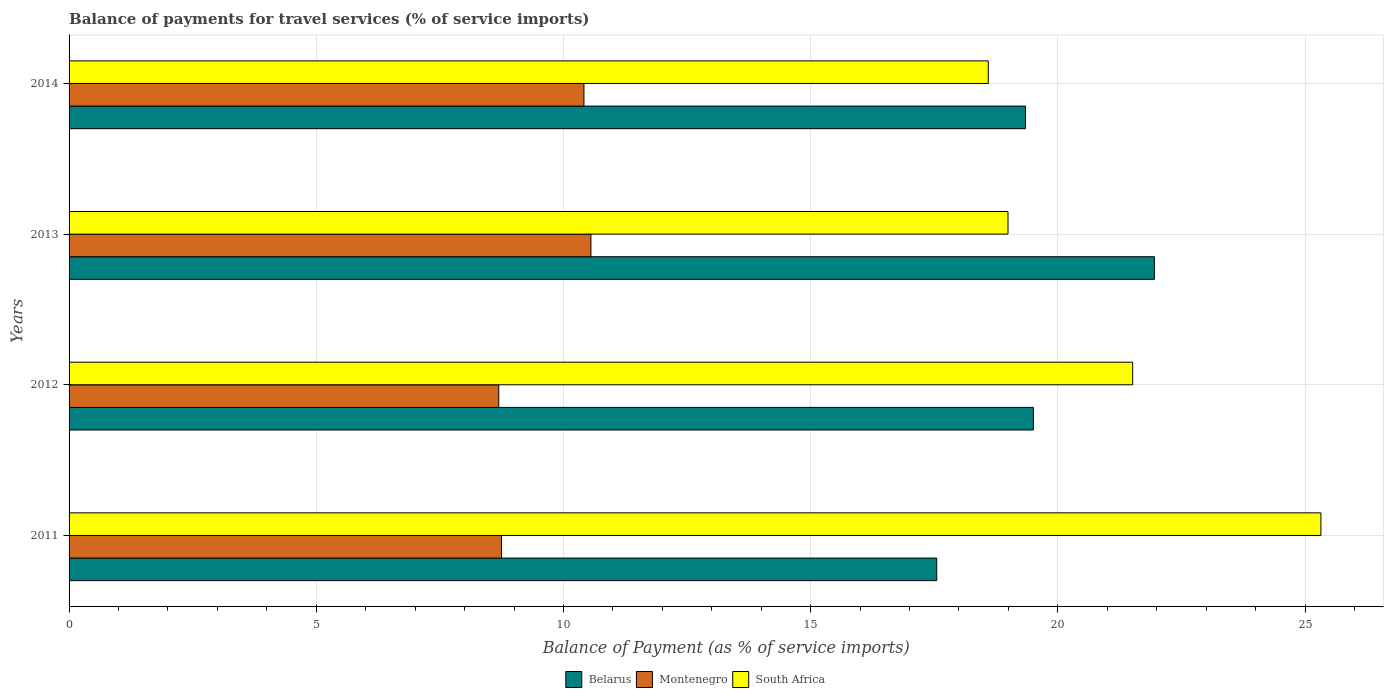How many bars are there on the 2nd tick from the top?
Offer a very short reply. 3. How many bars are there on the 4th tick from the bottom?
Ensure brevity in your answer.  3. What is the label of the 3rd group of bars from the top?
Provide a short and direct response. 2012. In how many cases, is the number of bars for a given year not equal to the number of legend labels?
Your answer should be compact. 0. What is the balance of payments for travel services in Montenegro in 2014?
Your answer should be very brief. 10.41. Across all years, what is the maximum balance of payments for travel services in South Africa?
Provide a succinct answer. 25.32. Across all years, what is the minimum balance of payments for travel services in Montenegro?
Ensure brevity in your answer.  8.69. In which year was the balance of payments for travel services in Belarus minimum?
Your answer should be compact. 2011. What is the total balance of payments for travel services in Belarus in the graph?
Keep it short and to the point. 78.35. What is the difference between the balance of payments for travel services in South Africa in 2012 and that in 2013?
Your answer should be compact. 2.52. What is the difference between the balance of payments for travel services in South Africa in 2013 and the balance of payments for travel services in Montenegro in 2012?
Ensure brevity in your answer.  10.3. What is the average balance of payments for travel services in Belarus per year?
Your answer should be very brief. 19.59. In the year 2014, what is the difference between the balance of payments for travel services in Belarus and balance of payments for travel services in South Africa?
Your answer should be compact. 0.75. In how many years, is the balance of payments for travel services in Belarus greater than 15 %?
Your answer should be very brief. 4. What is the ratio of the balance of payments for travel services in Montenegro in 2013 to that in 2014?
Provide a short and direct response. 1.01. Is the balance of payments for travel services in Belarus in 2012 less than that in 2014?
Keep it short and to the point. No. What is the difference between the highest and the second highest balance of payments for travel services in Belarus?
Your response must be concise. 2.45. What is the difference between the highest and the lowest balance of payments for travel services in Belarus?
Provide a succinct answer. 4.4. In how many years, is the balance of payments for travel services in South Africa greater than the average balance of payments for travel services in South Africa taken over all years?
Provide a short and direct response. 2. Is the sum of the balance of payments for travel services in South Africa in 2012 and 2014 greater than the maximum balance of payments for travel services in Belarus across all years?
Offer a very short reply. Yes. What does the 3rd bar from the top in 2014 represents?
Provide a short and direct response. Belarus. What does the 1st bar from the bottom in 2012 represents?
Make the answer very short. Belarus. How many bars are there?
Keep it short and to the point. 12. Are all the bars in the graph horizontal?
Ensure brevity in your answer.  Yes. What is the difference between two consecutive major ticks on the X-axis?
Your response must be concise. 5. Are the values on the major ticks of X-axis written in scientific E-notation?
Offer a terse response. No. Where does the legend appear in the graph?
Offer a terse response. Bottom center. What is the title of the graph?
Make the answer very short. Balance of payments for travel services (% of service imports). Does "St. Kitts and Nevis" appear as one of the legend labels in the graph?
Provide a succinct answer. No. What is the label or title of the X-axis?
Offer a very short reply. Balance of Payment (as % of service imports). What is the label or title of the Y-axis?
Provide a short and direct response. Years. What is the Balance of Payment (as % of service imports) in Belarus in 2011?
Offer a terse response. 17.55. What is the Balance of Payment (as % of service imports) of Montenegro in 2011?
Keep it short and to the point. 8.75. What is the Balance of Payment (as % of service imports) of South Africa in 2011?
Offer a terse response. 25.32. What is the Balance of Payment (as % of service imports) in Belarus in 2012?
Your answer should be compact. 19.5. What is the Balance of Payment (as % of service imports) in Montenegro in 2012?
Keep it short and to the point. 8.69. What is the Balance of Payment (as % of service imports) in South Africa in 2012?
Your response must be concise. 21.51. What is the Balance of Payment (as % of service imports) in Belarus in 2013?
Offer a terse response. 21.95. What is the Balance of Payment (as % of service imports) of Montenegro in 2013?
Keep it short and to the point. 10.56. What is the Balance of Payment (as % of service imports) in South Africa in 2013?
Provide a succinct answer. 18.99. What is the Balance of Payment (as % of service imports) in Belarus in 2014?
Give a very brief answer. 19.35. What is the Balance of Payment (as % of service imports) of Montenegro in 2014?
Provide a succinct answer. 10.41. What is the Balance of Payment (as % of service imports) of South Africa in 2014?
Ensure brevity in your answer.  18.59. Across all years, what is the maximum Balance of Payment (as % of service imports) in Belarus?
Offer a very short reply. 21.95. Across all years, what is the maximum Balance of Payment (as % of service imports) of Montenegro?
Make the answer very short. 10.56. Across all years, what is the maximum Balance of Payment (as % of service imports) in South Africa?
Give a very brief answer. 25.32. Across all years, what is the minimum Balance of Payment (as % of service imports) of Belarus?
Provide a short and direct response. 17.55. Across all years, what is the minimum Balance of Payment (as % of service imports) in Montenegro?
Give a very brief answer. 8.69. Across all years, what is the minimum Balance of Payment (as % of service imports) of South Africa?
Keep it short and to the point. 18.59. What is the total Balance of Payment (as % of service imports) in Belarus in the graph?
Give a very brief answer. 78.35. What is the total Balance of Payment (as % of service imports) in Montenegro in the graph?
Make the answer very short. 38.41. What is the total Balance of Payment (as % of service imports) in South Africa in the graph?
Offer a very short reply. 84.42. What is the difference between the Balance of Payment (as % of service imports) in Belarus in 2011 and that in 2012?
Your answer should be very brief. -1.96. What is the difference between the Balance of Payment (as % of service imports) in Montenegro in 2011 and that in 2012?
Your response must be concise. 0.06. What is the difference between the Balance of Payment (as % of service imports) of South Africa in 2011 and that in 2012?
Keep it short and to the point. 3.81. What is the difference between the Balance of Payment (as % of service imports) of Belarus in 2011 and that in 2013?
Offer a terse response. -4.4. What is the difference between the Balance of Payment (as % of service imports) in Montenegro in 2011 and that in 2013?
Offer a very short reply. -1.81. What is the difference between the Balance of Payment (as % of service imports) of South Africa in 2011 and that in 2013?
Your answer should be compact. 6.33. What is the difference between the Balance of Payment (as % of service imports) of Belarus in 2011 and that in 2014?
Provide a succinct answer. -1.8. What is the difference between the Balance of Payment (as % of service imports) in Montenegro in 2011 and that in 2014?
Give a very brief answer. -1.67. What is the difference between the Balance of Payment (as % of service imports) of South Africa in 2011 and that in 2014?
Make the answer very short. 6.73. What is the difference between the Balance of Payment (as % of service imports) in Belarus in 2012 and that in 2013?
Provide a short and direct response. -2.45. What is the difference between the Balance of Payment (as % of service imports) of Montenegro in 2012 and that in 2013?
Offer a very short reply. -1.86. What is the difference between the Balance of Payment (as % of service imports) in South Africa in 2012 and that in 2013?
Offer a terse response. 2.52. What is the difference between the Balance of Payment (as % of service imports) in Belarus in 2012 and that in 2014?
Make the answer very short. 0.16. What is the difference between the Balance of Payment (as % of service imports) of Montenegro in 2012 and that in 2014?
Ensure brevity in your answer.  -1.72. What is the difference between the Balance of Payment (as % of service imports) in South Africa in 2012 and that in 2014?
Provide a short and direct response. 2.92. What is the difference between the Balance of Payment (as % of service imports) of Belarus in 2013 and that in 2014?
Your response must be concise. 2.61. What is the difference between the Balance of Payment (as % of service imports) in Montenegro in 2013 and that in 2014?
Your response must be concise. 0.14. What is the difference between the Balance of Payment (as % of service imports) of South Africa in 2013 and that in 2014?
Offer a terse response. 0.4. What is the difference between the Balance of Payment (as % of service imports) of Belarus in 2011 and the Balance of Payment (as % of service imports) of Montenegro in 2012?
Offer a terse response. 8.86. What is the difference between the Balance of Payment (as % of service imports) of Belarus in 2011 and the Balance of Payment (as % of service imports) of South Africa in 2012?
Make the answer very short. -3.96. What is the difference between the Balance of Payment (as % of service imports) of Montenegro in 2011 and the Balance of Payment (as % of service imports) of South Africa in 2012?
Offer a very short reply. -12.77. What is the difference between the Balance of Payment (as % of service imports) in Belarus in 2011 and the Balance of Payment (as % of service imports) in Montenegro in 2013?
Your answer should be very brief. 6.99. What is the difference between the Balance of Payment (as % of service imports) in Belarus in 2011 and the Balance of Payment (as % of service imports) in South Africa in 2013?
Give a very brief answer. -1.44. What is the difference between the Balance of Payment (as % of service imports) in Montenegro in 2011 and the Balance of Payment (as % of service imports) in South Africa in 2013?
Make the answer very short. -10.24. What is the difference between the Balance of Payment (as % of service imports) in Belarus in 2011 and the Balance of Payment (as % of service imports) in Montenegro in 2014?
Ensure brevity in your answer.  7.14. What is the difference between the Balance of Payment (as % of service imports) in Belarus in 2011 and the Balance of Payment (as % of service imports) in South Africa in 2014?
Keep it short and to the point. -1.04. What is the difference between the Balance of Payment (as % of service imports) of Montenegro in 2011 and the Balance of Payment (as % of service imports) of South Africa in 2014?
Give a very brief answer. -9.85. What is the difference between the Balance of Payment (as % of service imports) in Belarus in 2012 and the Balance of Payment (as % of service imports) in Montenegro in 2013?
Provide a short and direct response. 8.95. What is the difference between the Balance of Payment (as % of service imports) of Belarus in 2012 and the Balance of Payment (as % of service imports) of South Africa in 2013?
Offer a terse response. 0.51. What is the difference between the Balance of Payment (as % of service imports) in Montenegro in 2012 and the Balance of Payment (as % of service imports) in South Africa in 2013?
Keep it short and to the point. -10.3. What is the difference between the Balance of Payment (as % of service imports) of Belarus in 2012 and the Balance of Payment (as % of service imports) of Montenegro in 2014?
Your response must be concise. 9.09. What is the difference between the Balance of Payment (as % of service imports) of Belarus in 2012 and the Balance of Payment (as % of service imports) of South Africa in 2014?
Give a very brief answer. 0.91. What is the difference between the Balance of Payment (as % of service imports) of Montenegro in 2012 and the Balance of Payment (as % of service imports) of South Africa in 2014?
Provide a succinct answer. -9.9. What is the difference between the Balance of Payment (as % of service imports) of Belarus in 2013 and the Balance of Payment (as % of service imports) of Montenegro in 2014?
Your answer should be compact. 11.54. What is the difference between the Balance of Payment (as % of service imports) in Belarus in 2013 and the Balance of Payment (as % of service imports) in South Africa in 2014?
Ensure brevity in your answer.  3.36. What is the difference between the Balance of Payment (as % of service imports) in Montenegro in 2013 and the Balance of Payment (as % of service imports) in South Africa in 2014?
Your answer should be very brief. -8.04. What is the average Balance of Payment (as % of service imports) in Belarus per year?
Offer a very short reply. 19.59. What is the average Balance of Payment (as % of service imports) of Montenegro per year?
Keep it short and to the point. 9.6. What is the average Balance of Payment (as % of service imports) of South Africa per year?
Your response must be concise. 21.1. In the year 2011, what is the difference between the Balance of Payment (as % of service imports) in Belarus and Balance of Payment (as % of service imports) in Montenegro?
Keep it short and to the point. 8.8. In the year 2011, what is the difference between the Balance of Payment (as % of service imports) in Belarus and Balance of Payment (as % of service imports) in South Africa?
Keep it short and to the point. -7.77. In the year 2011, what is the difference between the Balance of Payment (as % of service imports) of Montenegro and Balance of Payment (as % of service imports) of South Africa?
Offer a very short reply. -16.57. In the year 2012, what is the difference between the Balance of Payment (as % of service imports) in Belarus and Balance of Payment (as % of service imports) in Montenegro?
Your response must be concise. 10.81. In the year 2012, what is the difference between the Balance of Payment (as % of service imports) of Belarus and Balance of Payment (as % of service imports) of South Africa?
Offer a very short reply. -2.01. In the year 2012, what is the difference between the Balance of Payment (as % of service imports) of Montenegro and Balance of Payment (as % of service imports) of South Africa?
Provide a short and direct response. -12.82. In the year 2013, what is the difference between the Balance of Payment (as % of service imports) of Belarus and Balance of Payment (as % of service imports) of Montenegro?
Your response must be concise. 11.4. In the year 2013, what is the difference between the Balance of Payment (as % of service imports) in Belarus and Balance of Payment (as % of service imports) in South Africa?
Provide a short and direct response. 2.96. In the year 2013, what is the difference between the Balance of Payment (as % of service imports) in Montenegro and Balance of Payment (as % of service imports) in South Africa?
Offer a terse response. -8.44. In the year 2014, what is the difference between the Balance of Payment (as % of service imports) of Belarus and Balance of Payment (as % of service imports) of Montenegro?
Make the answer very short. 8.93. In the year 2014, what is the difference between the Balance of Payment (as % of service imports) of Belarus and Balance of Payment (as % of service imports) of South Africa?
Ensure brevity in your answer.  0.75. In the year 2014, what is the difference between the Balance of Payment (as % of service imports) in Montenegro and Balance of Payment (as % of service imports) in South Africa?
Your answer should be compact. -8.18. What is the ratio of the Balance of Payment (as % of service imports) of Belarus in 2011 to that in 2012?
Your answer should be compact. 0.9. What is the ratio of the Balance of Payment (as % of service imports) in Montenegro in 2011 to that in 2012?
Keep it short and to the point. 1.01. What is the ratio of the Balance of Payment (as % of service imports) in South Africa in 2011 to that in 2012?
Keep it short and to the point. 1.18. What is the ratio of the Balance of Payment (as % of service imports) of Belarus in 2011 to that in 2013?
Provide a succinct answer. 0.8. What is the ratio of the Balance of Payment (as % of service imports) in Montenegro in 2011 to that in 2013?
Provide a short and direct response. 0.83. What is the ratio of the Balance of Payment (as % of service imports) of South Africa in 2011 to that in 2013?
Ensure brevity in your answer.  1.33. What is the ratio of the Balance of Payment (as % of service imports) in Belarus in 2011 to that in 2014?
Your response must be concise. 0.91. What is the ratio of the Balance of Payment (as % of service imports) of Montenegro in 2011 to that in 2014?
Keep it short and to the point. 0.84. What is the ratio of the Balance of Payment (as % of service imports) of South Africa in 2011 to that in 2014?
Your response must be concise. 1.36. What is the ratio of the Balance of Payment (as % of service imports) in Belarus in 2012 to that in 2013?
Offer a terse response. 0.89. What is the ratio of the Balance of Payment (as % of service imports) of Montenegro in 2012 to that in 2013?
Your answer should be compact. 0.82. What is the ratio of the Balance of Payment (as % of service imports) in South Africa in 2012 to that in 2013?
Keep it short and to the point. 1.13. What is the ratio of the Balance of Payment (as % of service imports) in Belarus in 2012 to that in 2014?
Provide a succinct answer. 1.01. What is the ratio of the Balance of Payment (as % of service imports) of Montenegro in 2012 to that in 2014?
Provide a short and direct response. 0.83. What is the ratio of the Balance of Payment (as % of service imports) in South Africa in 2012 to that in 2014?
Offer a terse response. 1.16. What is the ratio of the Balance of Payment (as % of service imports) of Belarus in 2013 to that in 2014?
Keep it short and to the point. 1.13. What is the ratio of the Balance of Payment (as % of service imports) of Montenegro in 2013 to that in 2014?
Your response must be concise. 1.01. What is the ratio of the Balance of Payment (as % of service imports) in South Africa in 2013 to that in 2014?
Provide a short and direct response. 1.02. What is the difference between the highest and the second highest Balance of Payment (as % of service imports) in Belarus?
Ensure brevity in your answer.  2.45. What is the difference between the highest and the second highest Balance of Payment (as % of service imports) in Montenegro?
Offer a very short reply. 0.14. What is the difference between the highest and the second highest Balance of Payment (as % of service imports) of South Africa?
Your response must be concise. 3.81. What is the difference between the highest and the lowest Balance of Payment (as % of service imports) in Belarus?
Ensure brevity in your answer.  4.4. What is the difference between the highest and the lowest Balance of Payment (as % of service imports) in Montenegro?
Provide a succinct answer. 1.86. What is the difference between the highest and the lowest Balance of Payment (as % of service imports) in South Africa?
Make the answer very short. 6.73. 